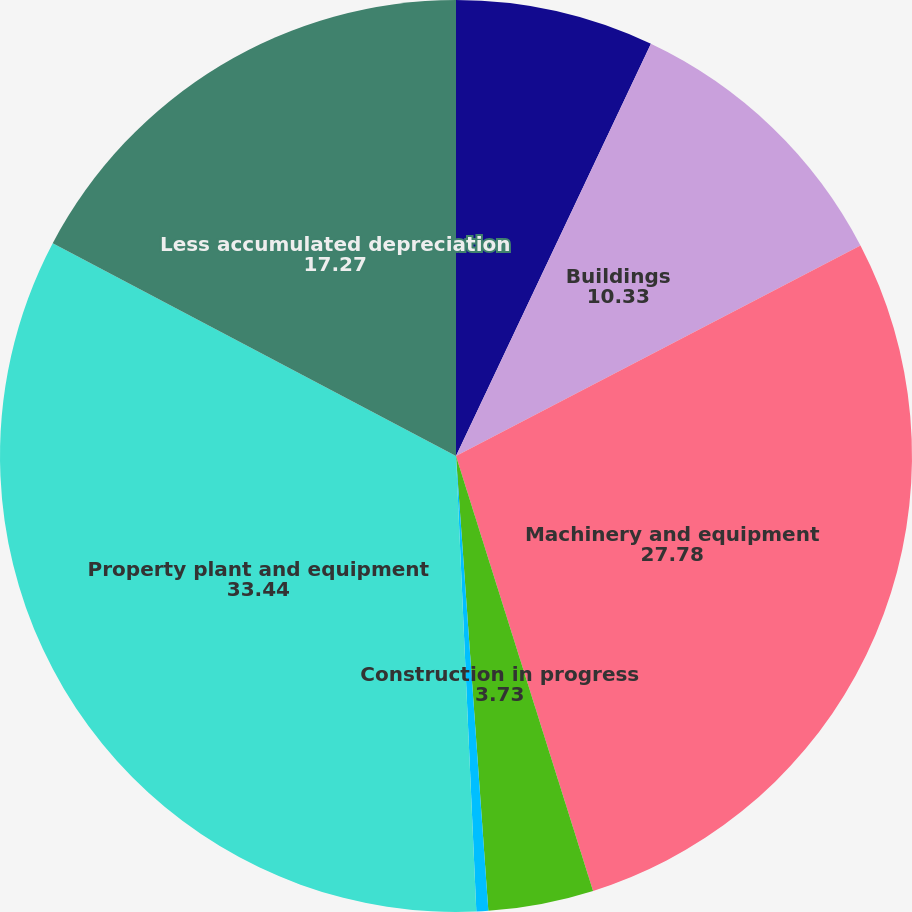Convert chart to OTSL. <chart><loc_0><loc_0><loc_500><loc_500><pie_chart><fcel>Land and land improvements<fcel>Buildings<fcel>Machinery and equipment<fcel>Construction in progress<fcel>Other<fcel>Property plant and equipment<fcel>Less accumulated depreciation<nl><fcel>7.03%<fcel>10.33%<fcel>27.78%<fcel>3.73%<fcel>0.42%<fcel>33.44%<fcel>17.27%<nl></chart> 